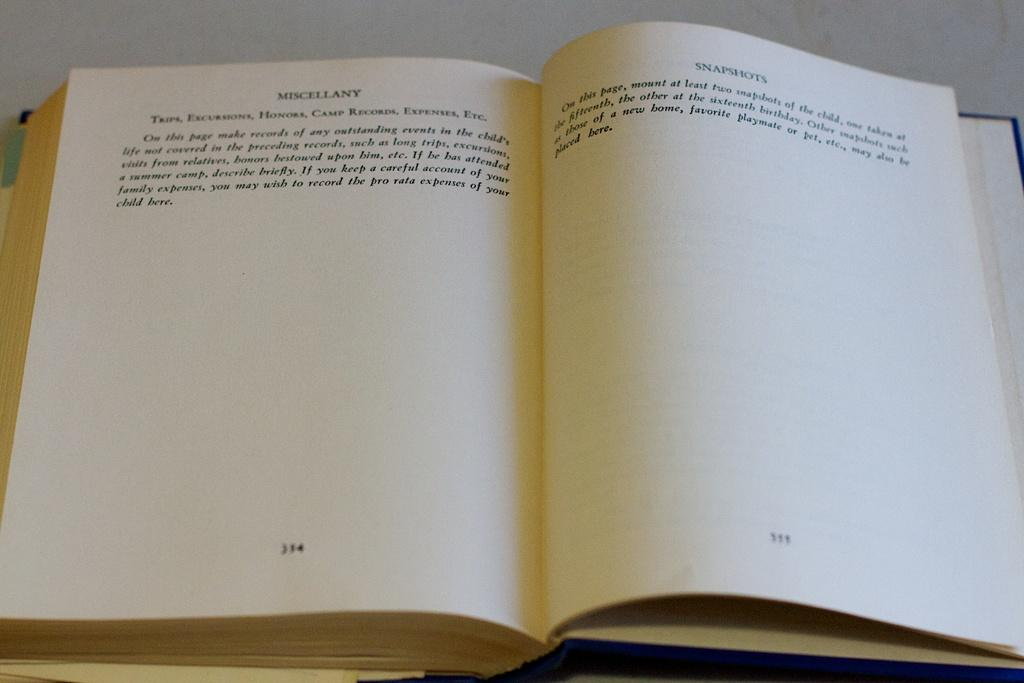<image>
Create a compact narrative representing the image presented. A book titled Snapshots is open to a page. 